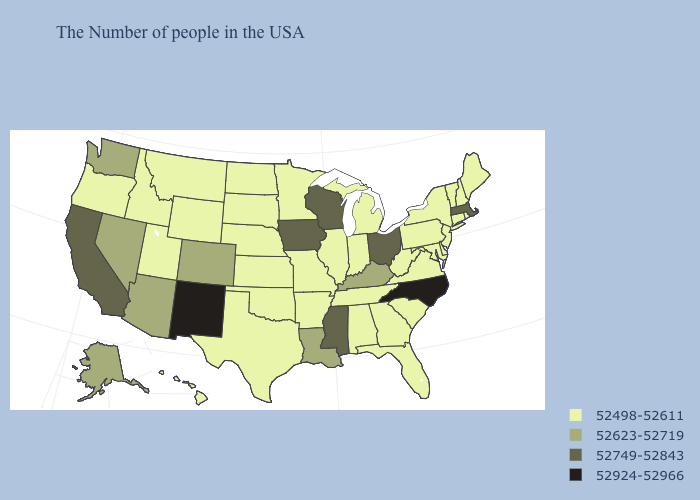Does the first symbol in the legend represent the smallest category?
Quick response, please. Yes. Among the states that border New Hampshire , does Massachusetts have the lowest value?
Short answer required. No. Does Mississippi have the lowest value in the South?
Answer briefly. No. What is the value of Vermont?
Give a very brief answer. 52498-52611. Does the first symbol in the legend represent the smallest category?
Give a very brief answer. Yes. Does Utah have the lowest value in the West?
Short answer required. Yes. Name the states that have a value in the range 52749-52843?
Short answer required. Massachusetts, Ohio, Wisconsin, Mississippi, Iowa, California. Which states have the highest value in the USA?
Give a very brief answer. North Carolina, New Mexico. What is the value of Delaware?
Quick response, please. 52498-52611. Among the states that border Louisiana , does Mississippi have the highest value?
Short answer required. Yes. Name the states that have a value in the range 52749-52843?
Quick response, please. Massachusetts, Ohio, Wisconsin, Mississippi, Iowa, California. Name the states that have a value in the range 52623-52719?
Answer briefly. Kentucky, Louisiana, Colorado, Arizona, Nevada, Washington, Alaska. Among the states that border Nebraska , which have the highest value?
Give a very brief answer. Iowa. Which states hav the highest value in the South?
Be succinct. North Carolina. What is the value of Arkansas?
Be succinct. 52498-52611. 